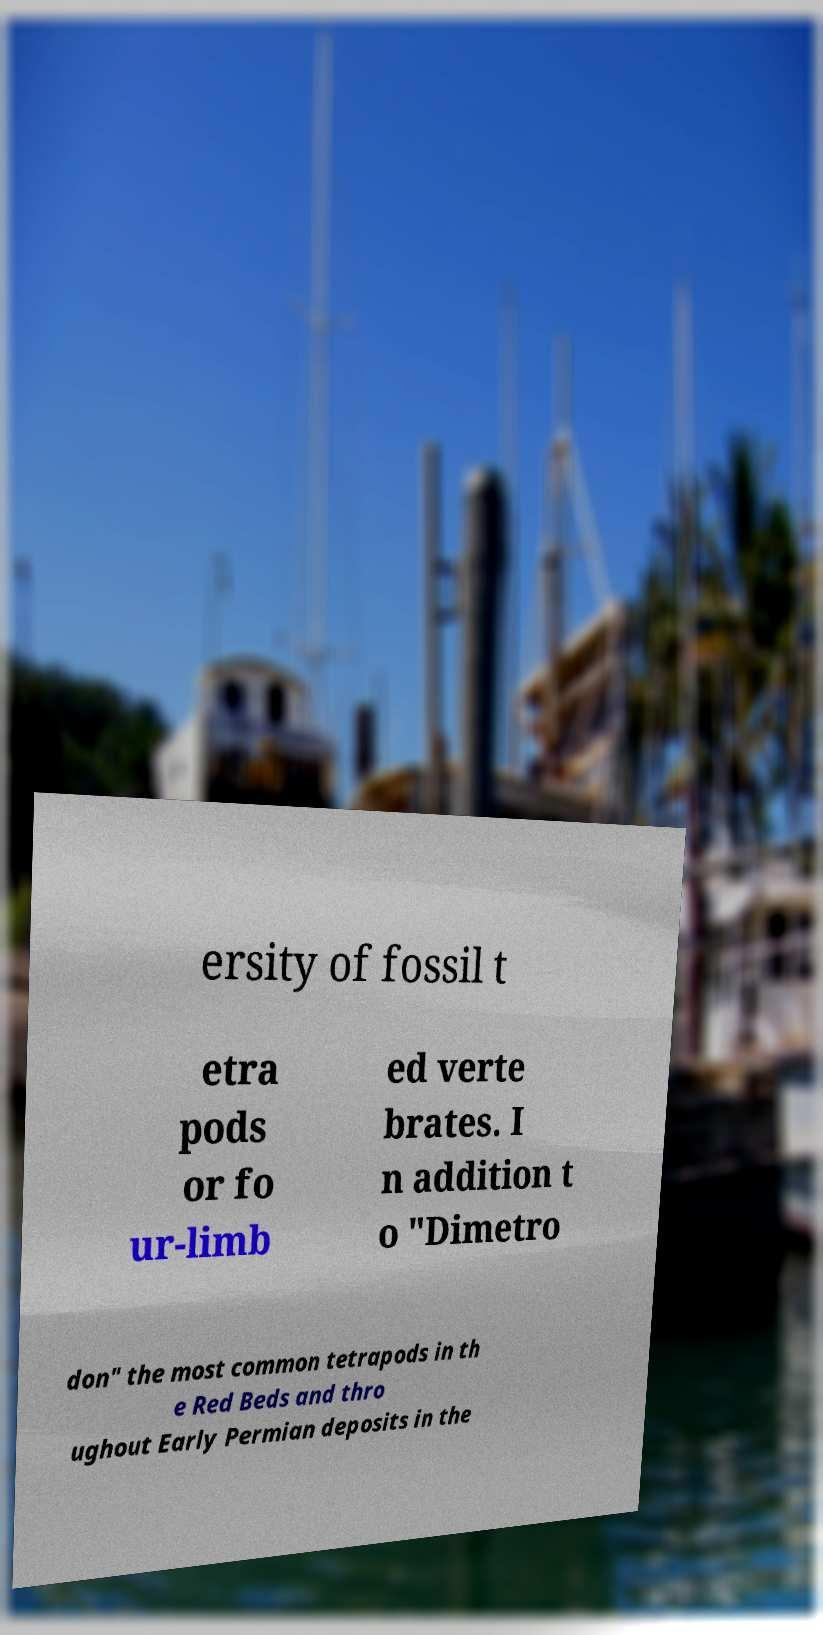For documentation purposes, I need the text within this image transcribed. Could you provide that? ersity of fossil t etra pods or fo ur-limb ed verte brates. I n addition t o "Dimetro don" the most common tetrapods in th e Red Beds and thro ughout Early Permian deposits in the 